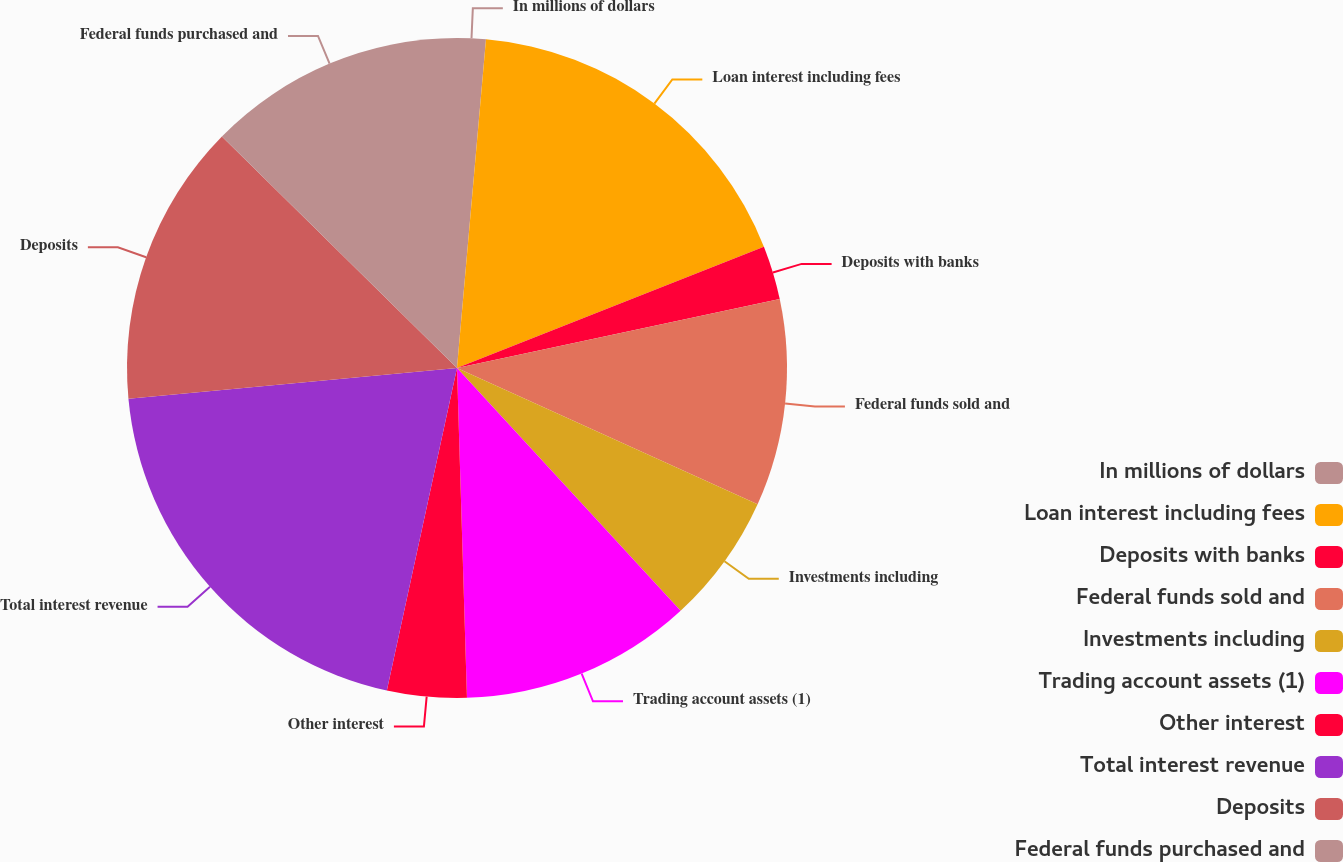Convert chart to OTSL. <chart><loc_0><loc_0><loc_500><loc_500><pie_chart><fcel>In millions of dollars<fcel>Loan interest including fees<fcel>Deposits with banks<fcel>Federal funds sold and<fcel>Investments including<fcel>Trading account assets (1)<fcel>Other interest<fcel>Total interest revenue<fcel>Deposits<fcel>Federal funds purchased and<nl><fcel>1.4%<fcel>17.61%<fcel>2.64%<fcel>10.12%<fcel>6.38%<fcel>11.37%<fcel>3.89%<fcel>20.1%<fcel>13.87%<fcel>12.62%<nl></chart> 